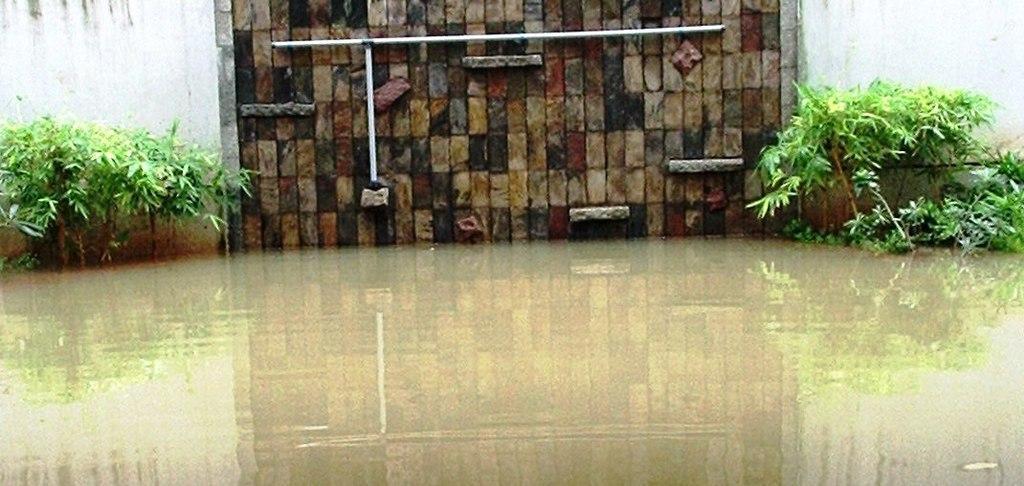Describe this image in one or two sentences. In this image I can see the water. In the background I can see the plants, rods and the wall. 